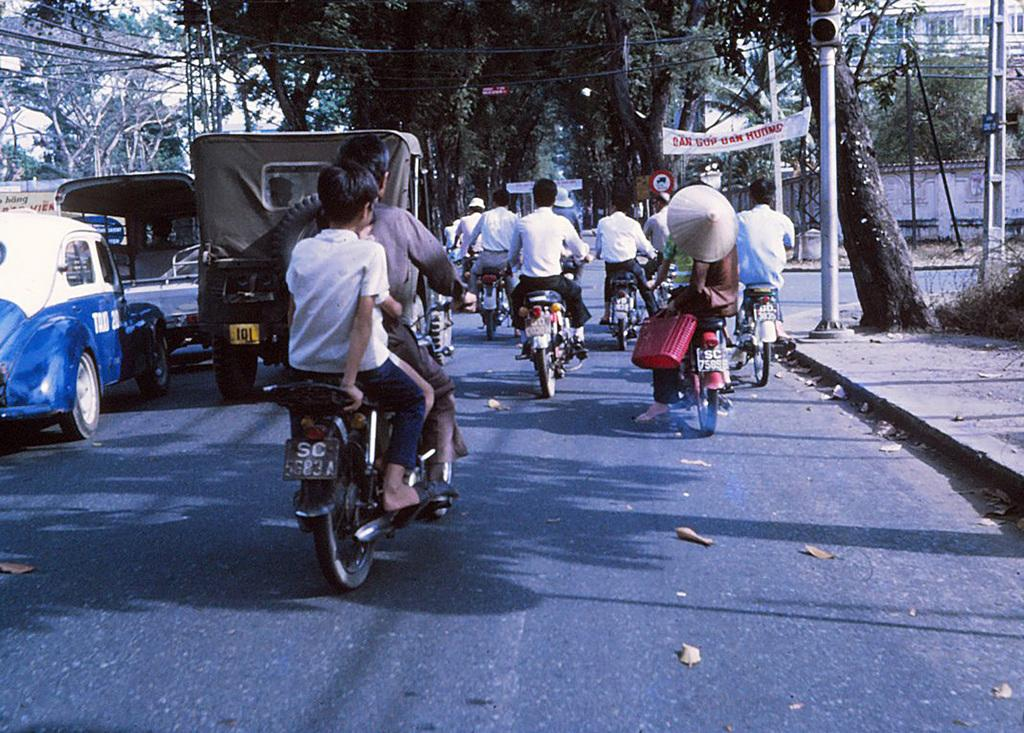What are the people in the image doing? The people in the image are riding bikes. What else can be seen on the road in the image? There are cars on the road in the image. What is visible in the background of the image? There are trees and a traffic signal in the background of the image. What additional information is provided by the banner in the image? There is a banner with some text in the image. What type of account is being discussed in the image? There is no mention of an account in the image; it features people riding bikes, cars on the road, trees, a traffic signal, and a banner with text. 